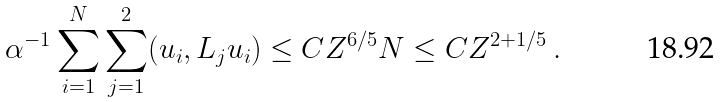Convert formula to latex. <formula><loc_0><loc_0><loc_500><loc_500>\alpha ^ { - 1 } \sum _ { i = 1 } ^ { N } \sum _ { j = 1 } ^ { 2 } ( u _ { i } , L _ { j } u _ { i } ) \leq C Z ^ { 6 / 5 } N \leq C Z ^ { 2 + 1 / 5 } \, .</formula> 